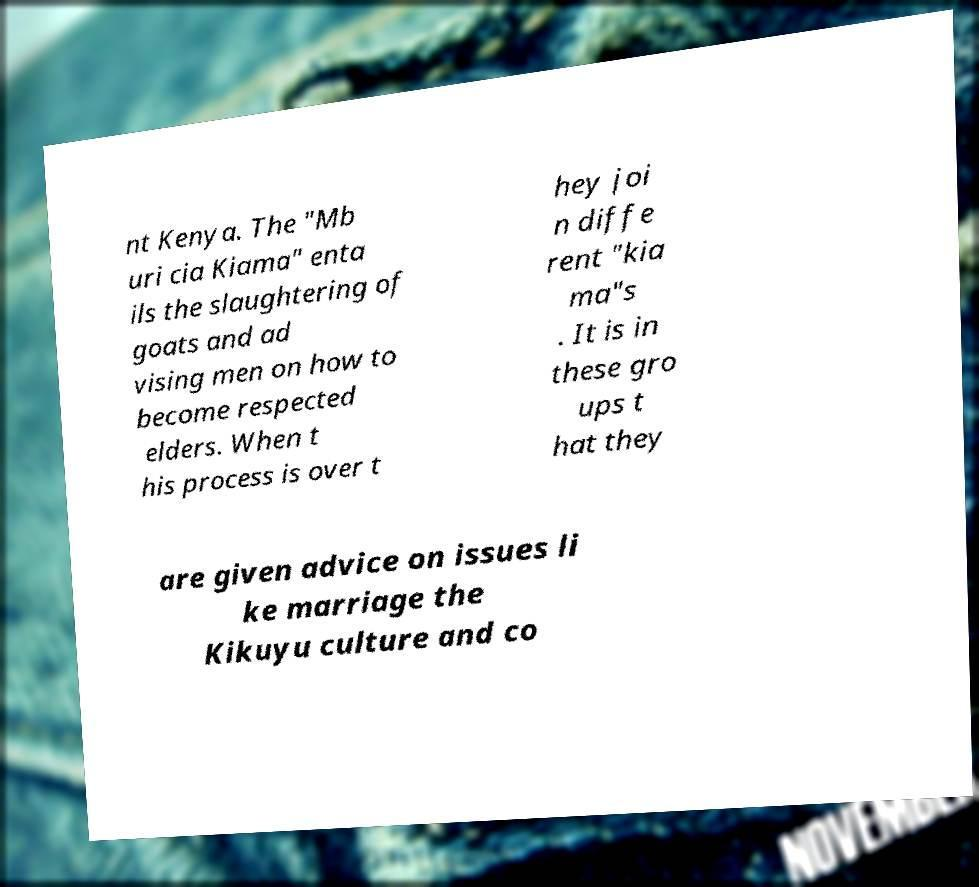Could you extract and type out the text from this image? nt Kenya. The "Mb uri cia Kiama" enta ils the slaughtering of goats and ad vising men on how to become respected elders. When t his process is over t hey joi n diffe rent "kia ma"s . It is in these gro ups t hat they are given advice on issues li ke marriage the Kikuyu culture and co 